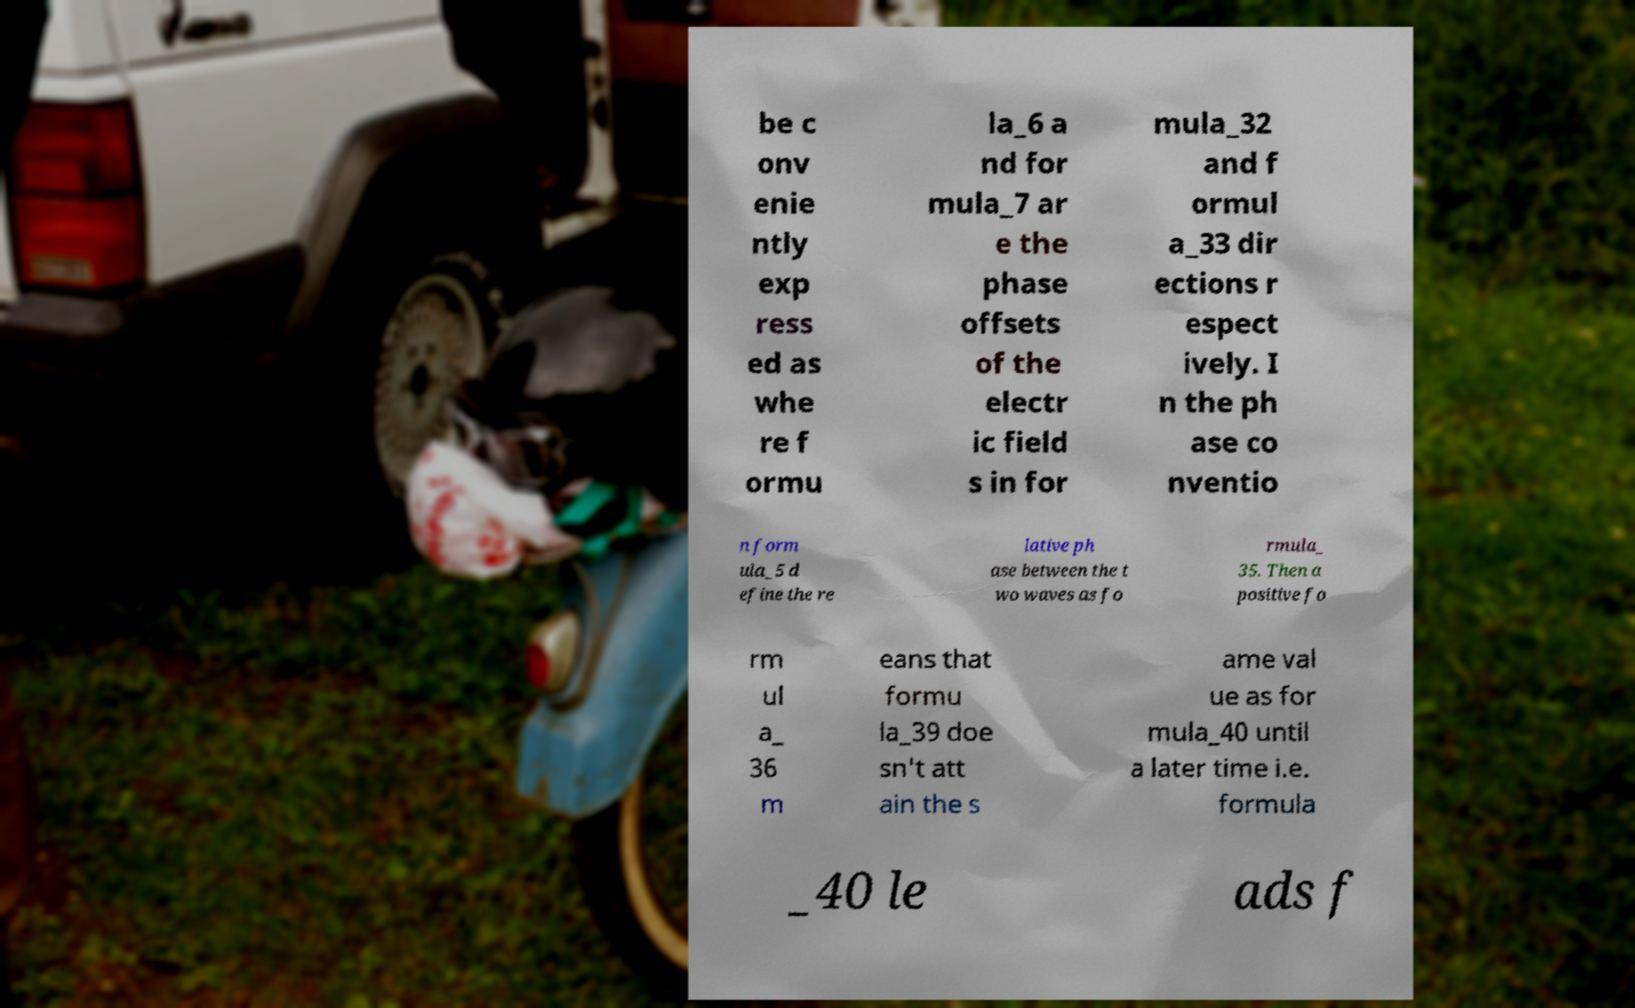Could you extract and type out the text from this image? be c onv enie ntly exp ress ed as whe re f ormu la_6 a nd for mula_7 ar e the phase offsets of the electr ic field s in for mula_32 and f ormul a_33 dir ections r espect ively. I n the ph ase co nventio n form ula_5 d efine the re lative ph ase between the t wo waves as fo rmula_ 35. Then a positive fo rm ul a_ 36 m eans that formu la_39 doe sn't att ain the s ame val ue as for mula_40 until a later time i.e. formula _40 le ads f 